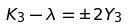<formula> <loc_0><loc_0><loc_500><loc_500>K _ { 3 } - \lambda = \pm 2 Y _ { 3 }</formula> 